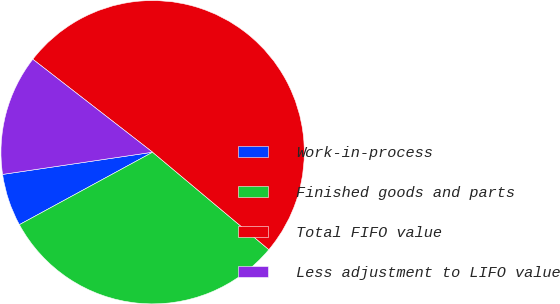Convert chart. <chart><loc_0><loc_0><loc_500><loc_500><pie_chart><fcel>Work-in-process<fcel>Finished goods and parts<fcel>Total FIFO value<fcel>Less adjustment to LIFO value<nl><fcel>5.59%<fcel>30.97%<fcel>50.6%<fcel>12.84%<nl></chart> 